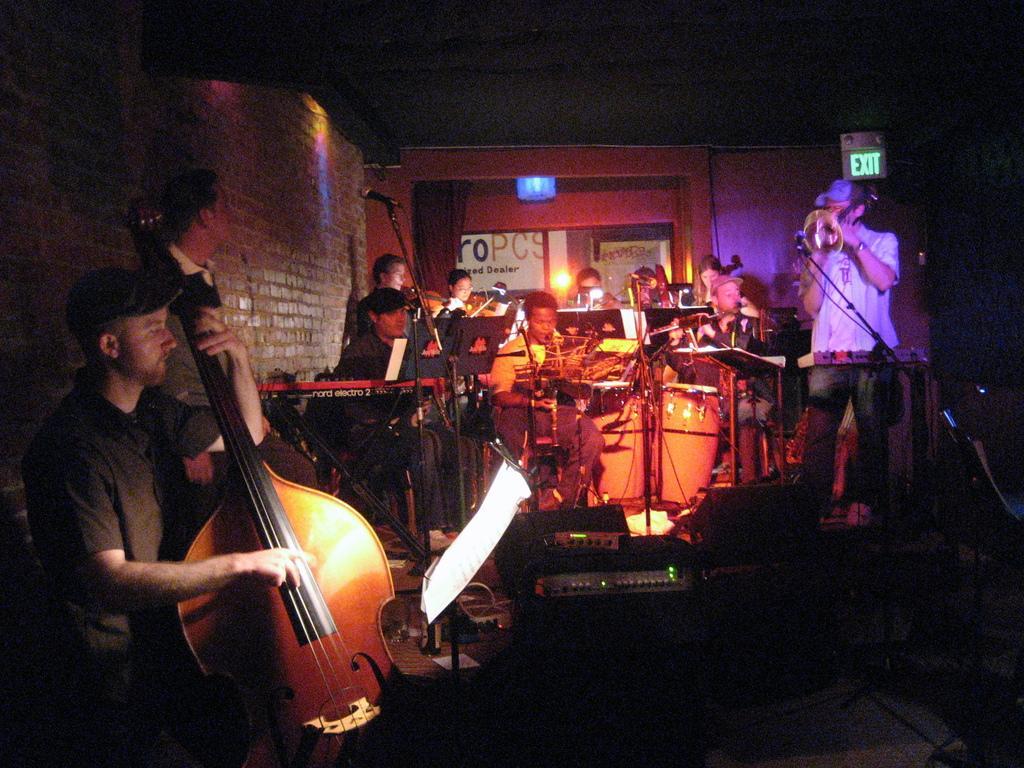Describe this image in one or two sentences. This image is clicked in a musical concert where it is clicked in a room. There are so many people in this image ,all of them are playing musical instruments. There is exit board on the top right corner and there is light on the top. There are so many wires. 